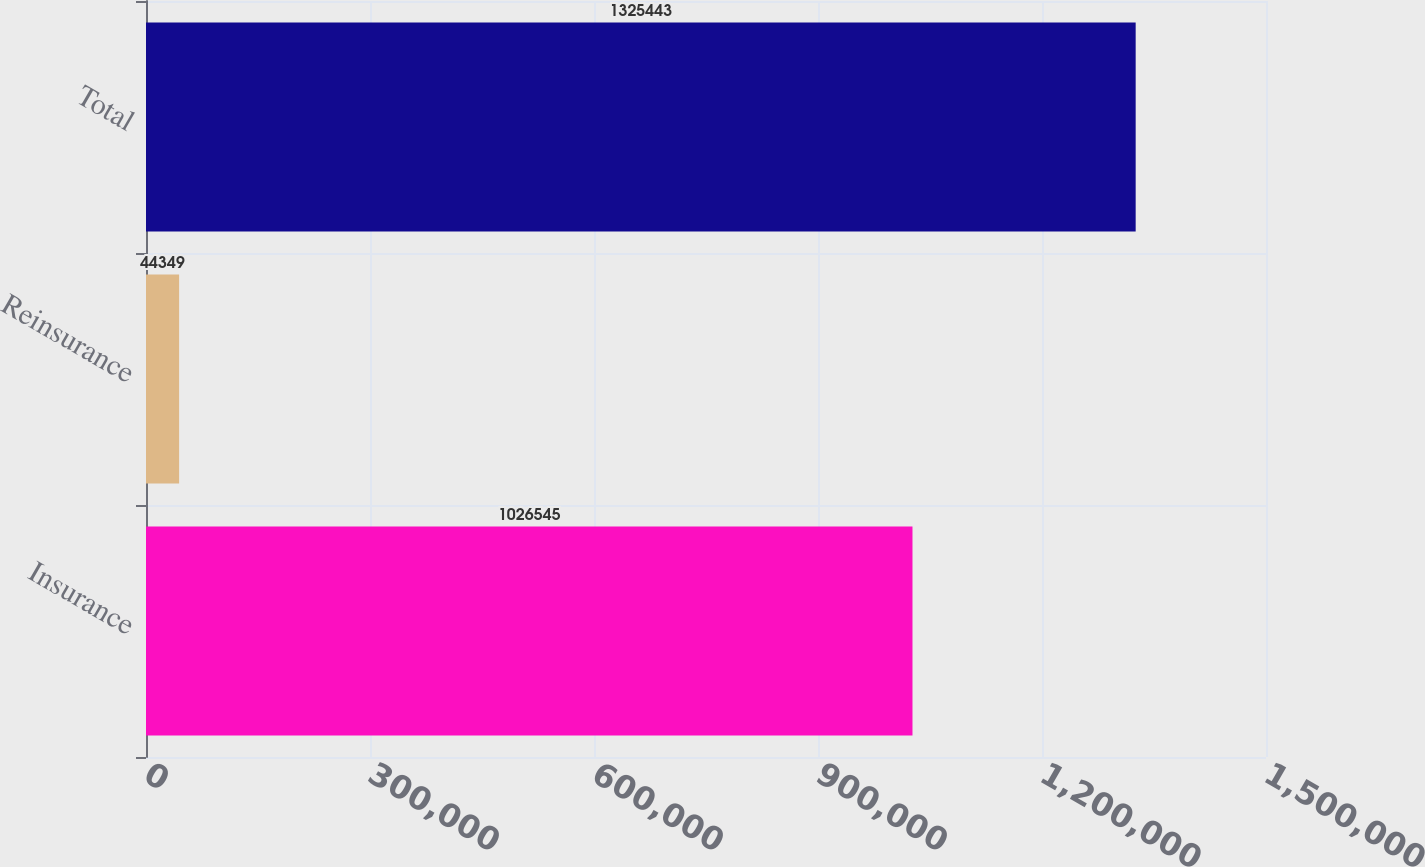<chart> <loc_0><loc_0><loc_500><loc_500><bar_chart><fcel>Insurance<fcel>Reinsurance<fcel>Total<nl><fcel>1.02654e+06<fcel>44349<fcel>1.32544e+06<nl></chart> 